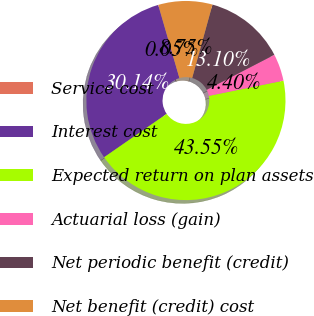<chart> <loc_0><loc_0><loc_500><loc_500><pie_chart><fcel>Service cost<fcel>Interest cost<fcel>Expected return on plan assets<fcel>Actuarial loss (gain)<fcel>Net periodic benefit (credit)<fcel>Net benefit (credit) cost<nl><fcel>0.05%<fcel>30.14%<fcel>43.55%<fcel>4.4%<fcel>13.1%<fcel>8.75%<nl></chart> 